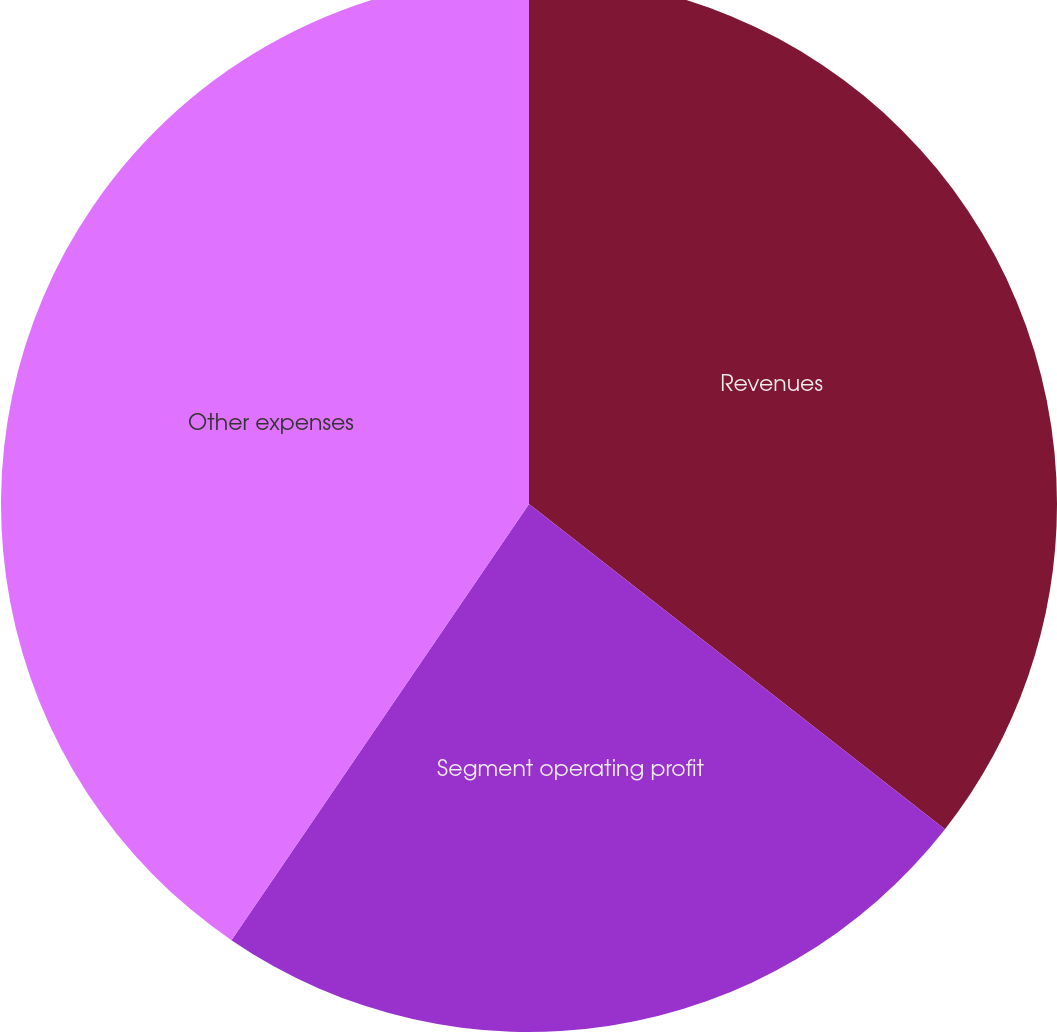Convert chart. <chart><loc_0><loc_0><loc_500><loc_500><pie_chart><fcel>Revenues<fcel>Segment operating profit<fcel>Other expenses<nl><fcel>35.56%<fcel>23.97%<fcel>40.47%<nl></chart> 